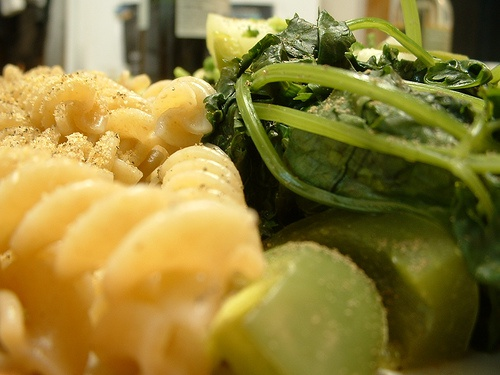Describe the objects in this image and their specific colors. I can see a broccoli in gray, black, darkgreen, and olive tones in this image. 